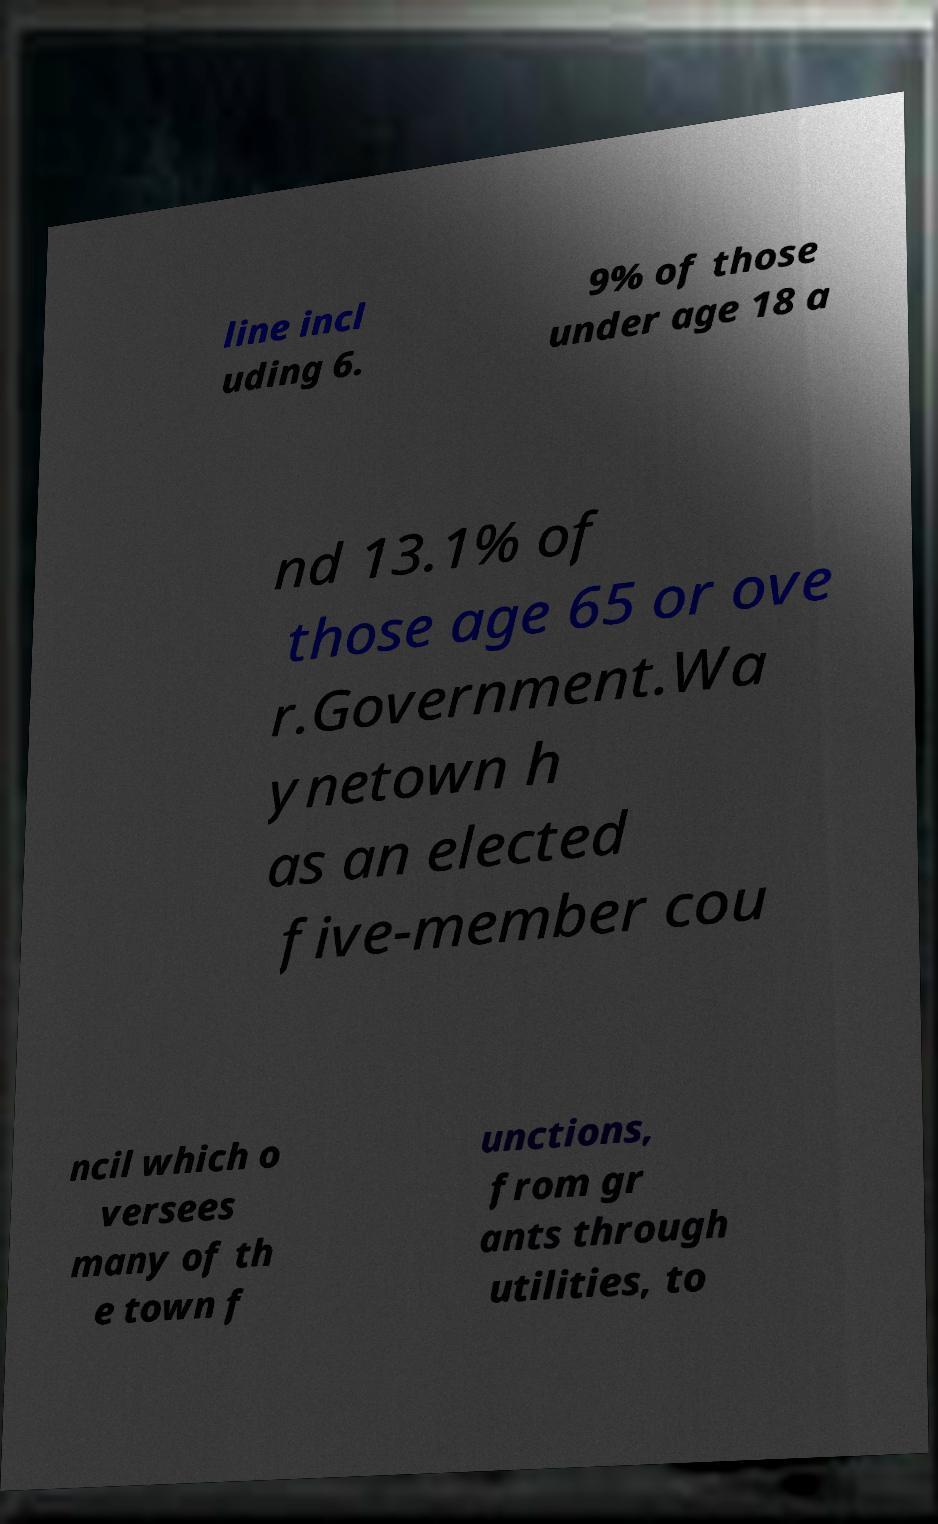Could you extract and type out the text from this image? line incl uding 6. 9% of those under age 18 a nd 13.1% of those age 65 or ove r.Government.Wa ynetown h as an elected five-member cou ncil which o versees many of th e town f unctions, from gr ants through utilities, to 